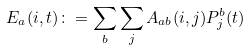<formula> <loc_0><loc_0><loc_500><loc_500>E _ { a } ( i , t ) \colon = \sum _ { b } \sum _ { j } A _ { a b } ( i , j ) P _ { j } ^ { b } ( t )</formula> 